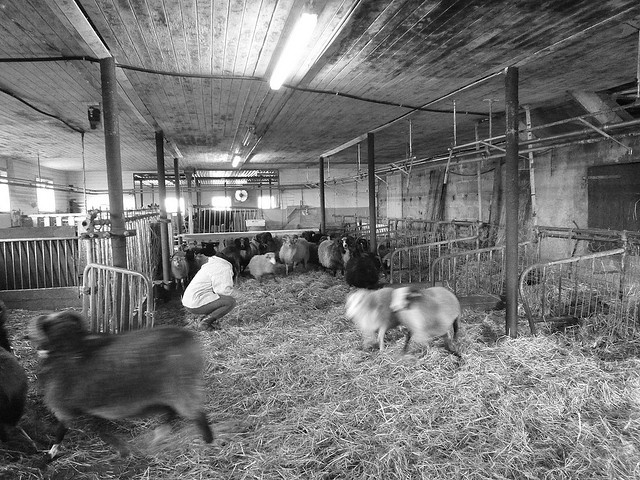Describe the objects in this image and their specific colors. I can see sheep in gray, black, and lightgray tones, sheep in gray, darkgray, lightgray, and black tones, people in gray, lightgray, black, and darkgray tones, sheep in gray, darkgray, lightgray, and black tones, and sheep in gray, black, and lightgray tones in this image. 